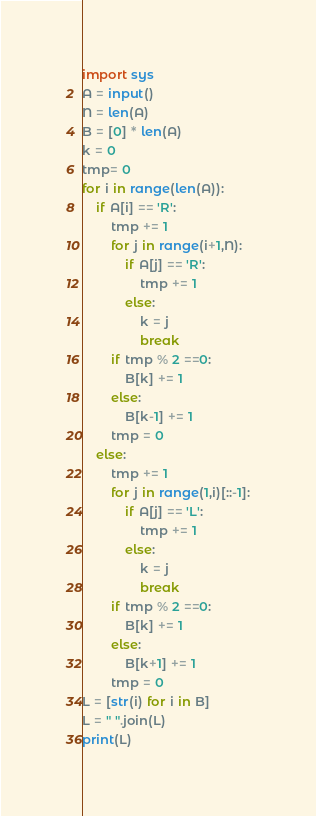<code> <loc_0><loc_0><loc_500><loc_500><_Python_>import sys
A = input()
N = len(A)
B = [0] * len(A)
k = 0
tmp= 0
for i in range(len(A)):
    if A[i] == 'R':
        tmp += 1
        for j in range(i+1,N):
            if A[j] == 'R':
                tmp += 1
            else:
                k = j
                break
        if tmp % 2 ==0:
            B[k] += 1
        else:
            B[k-1] += 1
        tmp = 0
    else:
        tmp += 1
        for j in range(1,i)[::-1]:
            if A[j] == 'L':
                tmp += 1
            else:
                k = j
                break
        if tmp % 2 ==0:
            B[k] += 1
        else:            
            B[k+1] += 1
        tmp = 0
L = [str(i) for i in B]
L = " ".join(L)
print(L)</code> 